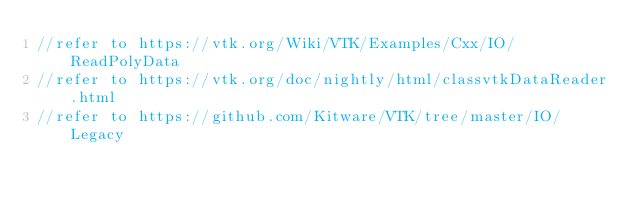<code> <loc_0><loc_0><loc_500><loc_500><_C++_>//refer to https://vtk.org/Wiki/VTK/Examples/Cxx/IO/ReadPolyData
//refer to https://vtk.org/doc/nightly/html/classvtkDataReader.html
//refer to https://github.com/Kitware/VTK/tree/master/IO/Legacy
</code> 